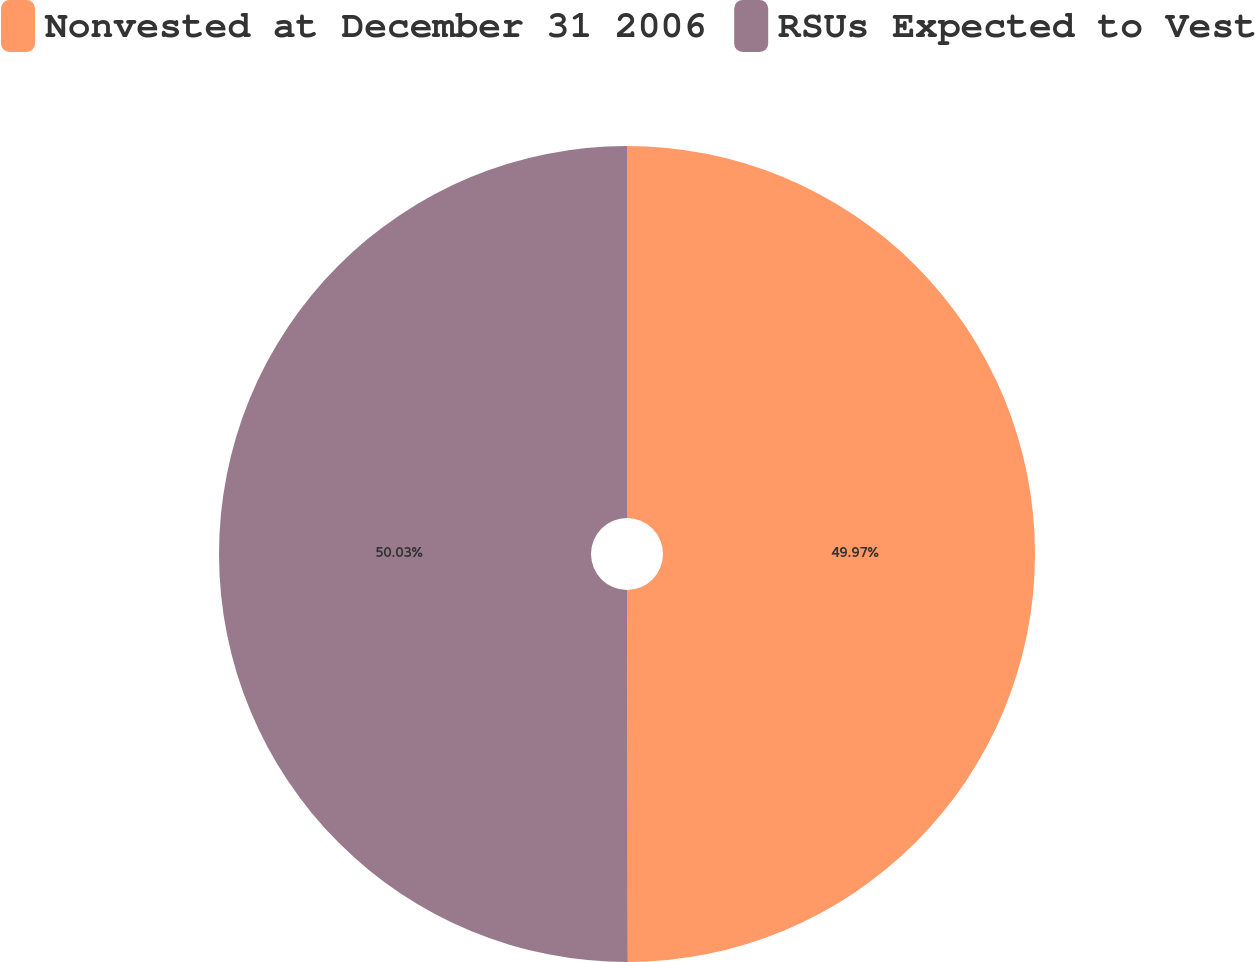Convert chart to OTSL. <chart><loc_0><loc_0><loc_500><loc_500><pie_chart><fcel>Nonvested at December 31 2006<fcel>RSUs Expected to Vest<nl><fcel>49.97%<fcel>50.03%<nl></chart> 